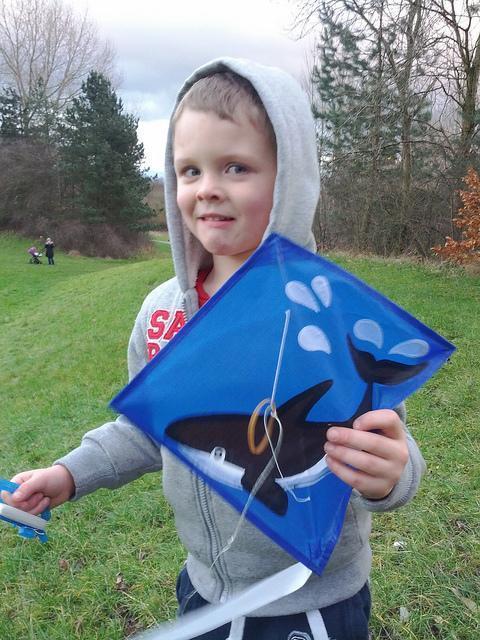What animal is on the kite?
From the following four choices, select the correct answer to address the question.
Options: Whale, echidna, dog, snake. Whale. 